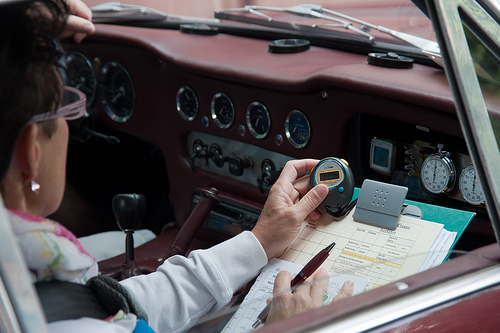Please provide a short description for this region: [0.14, 0.36, 0.16, 0.39]. The region depicts a middle-aged woman wearing stylish eyeglasses with thin metallic frames, adding a sophisticated touch to her appearance. 